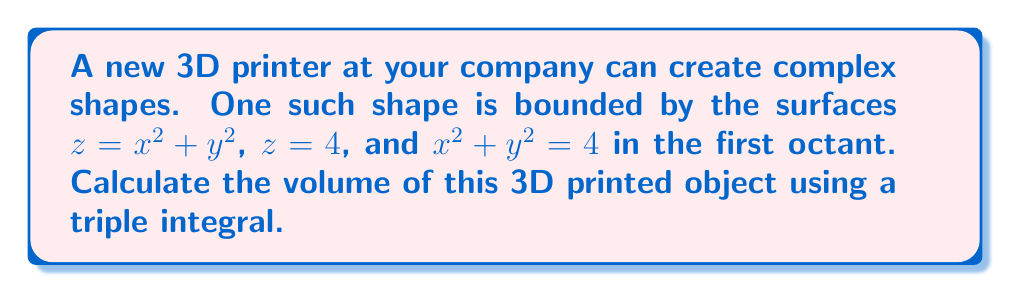Help me with this question. To solve this problem, we'll follow these steps:

1) Visualize the shape:
   The object is bounded by a paraboloid ($z = x^2 + y^2$), a horizontal plane ($z = 4$), and a vertical cylinder ($x^2 + y^2 = 4$) in the first octant.

2) Set up the triple integral:
   $$V = \iiint_V dV = \int_0^2 \int_0^{\sqrt{4-x^2}} \int_{x^2+y^2}^4 dz dy dx$$

3) Evaluate the innermost integral (z):
   $$V = \int_0^2 \int_0^{\sqrt{4-x^2}} [z]_{x^2+y^2}^4 dy dx$$
   $$V = \int_0^2 \int_0^{\sqrt{4-x^2}} (4 - (x^2+y^2)) dy dx$$

4) Evaluate the middle integral (y):
   $$V = \int_0^2 \left[4y - xy^2 - \frac{y^3}{3}\right]_0^{\sqrt{4-x^2}} dx$$
   $$V = \int_0^2 \left(4\sqrt{4-x^2} - x(4-x^2) - \frac{(4-x^2)^{3/2}}{3}\right) dx$$

5) Evaluate the outer integral (x):
   This is a complex integral. We can use the substitution $x = 2\sin\theta$ to simplify:
   $$V = \int_0^{\pi/2} \left(8\cos\theta - 8\sin\theta\cos^2\theta - \frac{8}{3}\cos^3\theta\right) 2\cos\theta d\theta$$
   $$V = 16\int_0^{\pi/2} (\cos^2\theta - \sin\theta\cos^3\theta - \frac{1}{3}\cos^4\theta) d\theta$$

6) Evaluate this integral:
   $$V = 16\left[\frac{\theta}{2} + \frac{\sin\theta\cos\theta}{4} + \frac{\sin\theta\cos^3\theta}{12} - \frac{1}{3}\left(\frac{3\theta}{8} + \frac{\sin2\theta}{16} + \frac{\sin4\theta}{64}\right)\right]_0^{\pi/2}$$

7) Compute the final result:
   $$V = 16\left(\frac{\pi}{4} - \frac{1}{3} \cdot \frac{3\pi}{16}\right) = 16 \cdot \frac{\pi}{6} = \frac{8\pi}{3}$$
Answer: $\frac{8\pi}{3}$ cubic units 